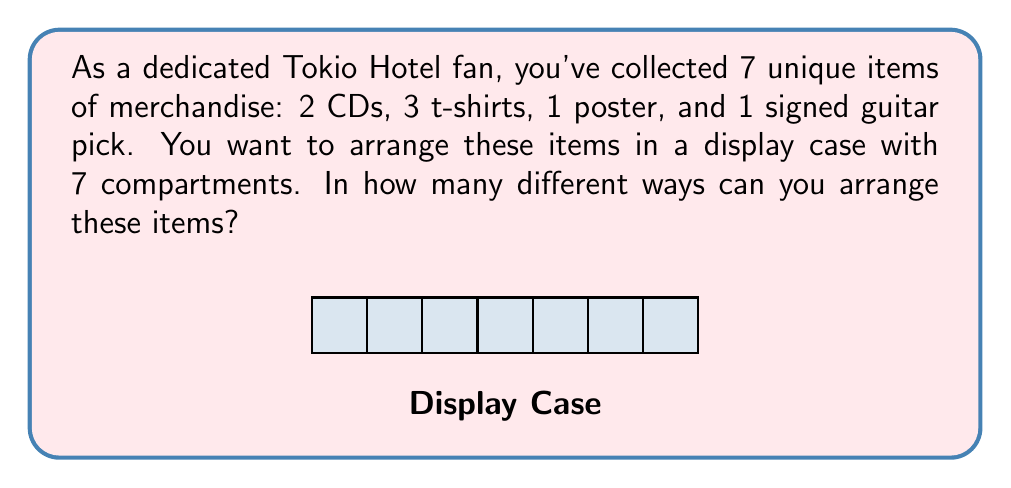Could you help me with this problem? Let's approach this step-by-step:

1) This is a permutation problem. We need to find the number of ways to arrange 7 distinct objects in 7 positions.

2) If all items were different, the answer would be 7! (7 factorial). However, we have some identical items:
   - 2 CDs (indistinguishable from each other)
   - 3 t-shirts (indistinguishable from each other)

3) When we have identical objects, we need to divide by the number of permutations of these identical objects to avoid overcounting.

4) The formula for this scenario is:

   $$\frac{7!}{2! \cdot 3!}$$

5) Let's break this down:
   - 7! accounts for all permutations if all items were different
   - We divide by 2! to account for the 2 identical CDs
   - We divide by 3! to account for the 3 identical t-shirts

6) Now, let's calculate:

   $$\frac{7!}{2! \cdot 3!} = \frac{7 \cdot 6 \cdot 5 \cdot 4 \cdot 3 \cdot 2 \cdot 1}{(2 \cdot 1) \cdot (3 \cdot 2 \cdot 1)} = \frac{5040}{12} = 420$$

Therefore, there are 420 unique ways to arrange the Tokio Hotel merchandise in the display case.
Answer: 420 